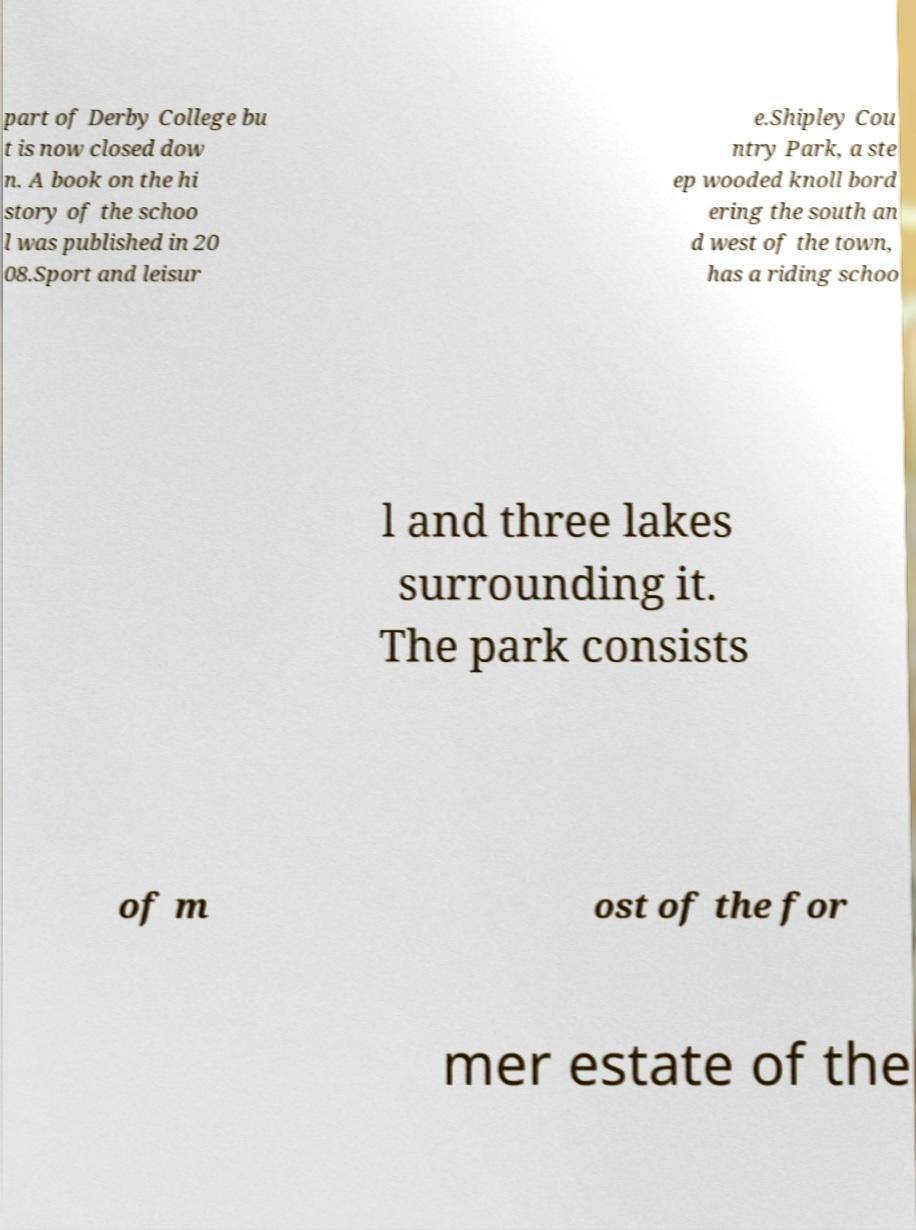Could you extract and type out the text from this image? part of Derby College bu t is now closed dow n. A book on the hi story of the schoo l was published in 20 08.Sport and leisur e.Shipley Cou ntry Park, a ste ep wooded knoll bord ering the south an d west of the town, has a riding schoo l and three lakes surrounding it. The park consists of m ost of the for mer estate of the 